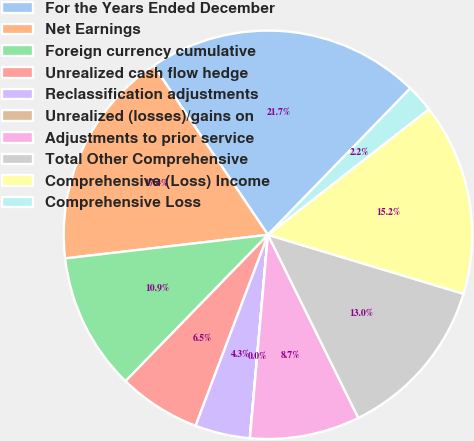<chart> <loc_0><loc_0><loc_500><loc_500><pie_chart><fcel>For the Years Ended December<fcel>Net Earnings<fcel>Foreign currency cumulative<fcel>Unrealized cash flow hedge<fcel>Reclassification adjustments<fcel>Unrealized (losses)/gains on<fcel>Adjustments to prior service<fcel>Total Other Comprehensive<fcel>Comprehensive (Loss) Income<fcel>Comprehensive Loss<nl><fcel>21.73%<fcel>17.39%<fcel>10.87%<fcel>6.52%<fcel>4.35%<fcel>0.01%<fcel>8.7%<fcel>13.04%<fcel>15.21%<fcel>2.18%<nl></chart> 